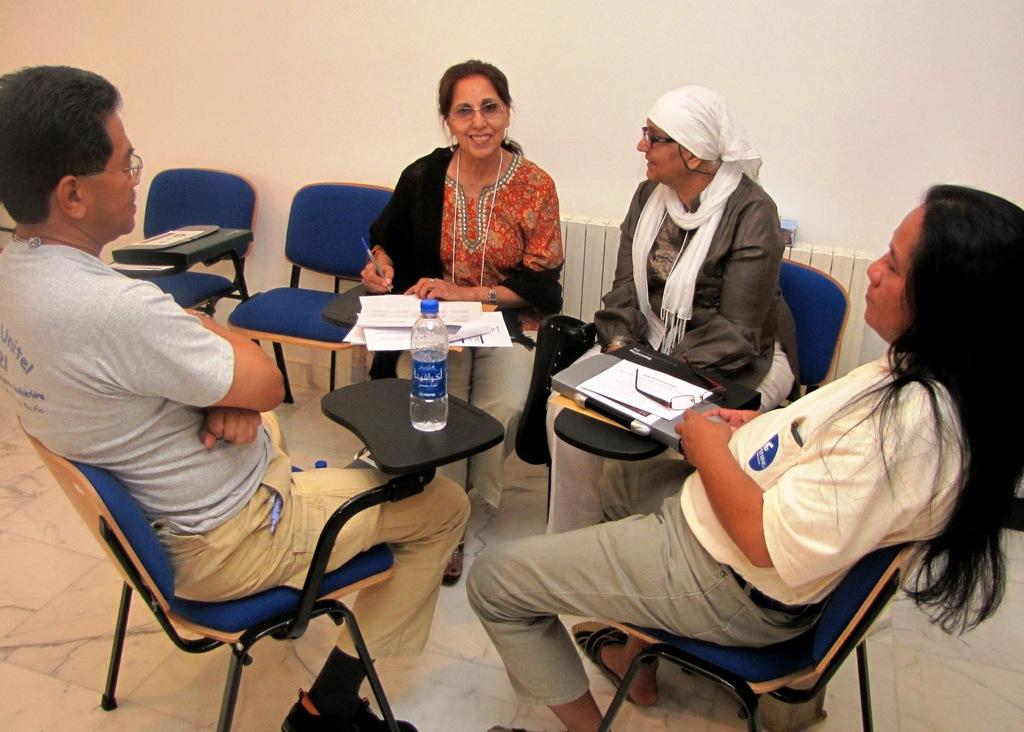What are the people in the image doing? The people in the image are sitting on chairs. What is present in the image besides the people? There is a table in the image. What can be seen on the table? There is a water bottle and papers on the table. Can you see a crown on any of the people in the image? There is no crown visible on any of the people in the image. Are there any rats present in the image? There are no rats present in the image. 